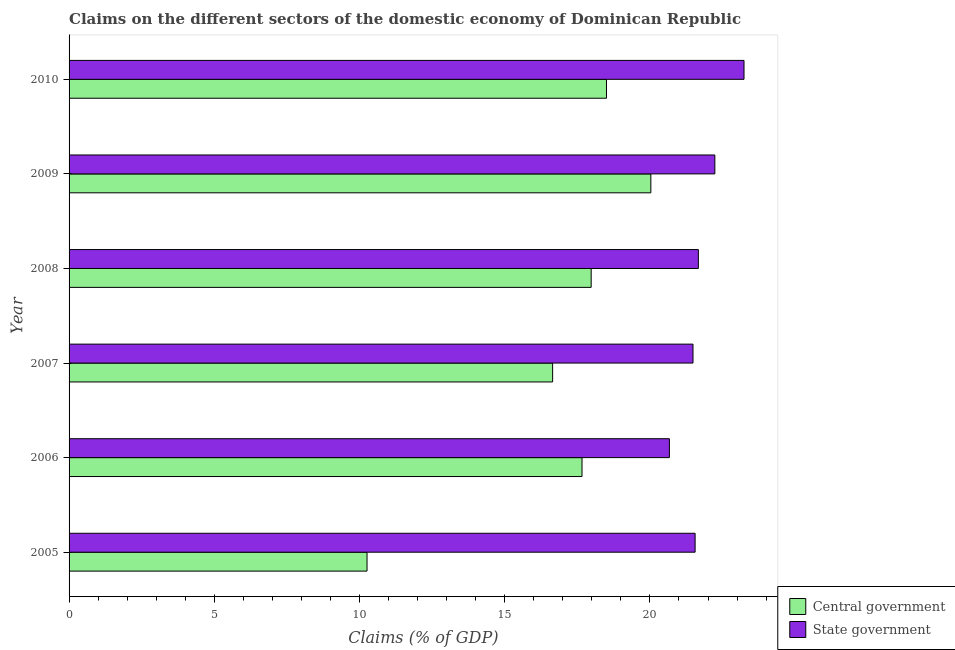How many different coloured bars are there?
Keep it short and to the point. 2. How many groups of bars are there?
Your response must be concise. 6. Are the number of bars per tick equal to the number of legend labels?
Keep it short and to the point. Yes. Are the number of bars on each tick of the Y-axis equal?
Provide a succinct answer. Yes. How many bars are there on the 6th tick from the top?
Your answer should be compact. 2. What is the label of the 2nd group of bars from the top?
Offer a very short reply. 2009. What is the claims on central government in 2008?
Provide a short and direct response. 17.98. Across all years, what is the maximum claims on state government?
Provide a succinct answer. 23.24. Across all years, what is the minimum claims on state government?
Give a very brief answer. 20.67. What is the total claims on central government in the graph?
Provide a short and direct response. 101.08. What is the difference between the claims on central government in 2006 and that in 2007?
Offer a very short reply. 1.01. What is the difference between the claims on state government in 2005 and the claims on central government in 2006?
Your answer should be compact. 3.89. What is the average claims on central government per year?
Your answer should be compact. 16.85. In the year 2009, what is the difference between the claims on central government and claims on state government?
Ensure brevity in your answer.  -2.2. Is the claims on state government in 2005 less than that in 2006?
Your response must be concise. No. Is the difference between the claims on state government in 2008 and 2009 greater than the difference between the claims on central government in 2008 and 2009?
Make the answer very short. Yes. What is the difference between the highest and the second highest claims on state government?
Give a very brief answer. 1. What is the difference between the highest and the lowest claims on central government?
Provide a succinct answer. 9.77. In how many years, is the claims on state government greater than the average claims on state government taken over all years?
Give a very brief answer. 2. Is the sum of the claims on central government in 2007 and 2010 greater than the maximum claims on state government across all years?
Give a very brief answer. Yes. What does the 2nd bar from the top in 2010 represents?
Keep it short and to the point. Central government. What does the 2nd bar from the bottom in 2005 represents?
Your answer should be very brief. State government. How many bars are there?
Keep it short and to the point. 12. Are all the bars in the graph horizontal?
Your response must be concise. Yes. How many years are there in the graph?
Give a very brief answer. 6. Does the graph contain grids?
Your answer should be very brief. No. How are the legend labels stacked?
Ensure brevity in your answer.  Vertical. What is the title of the graph?
Offer a terse response. Claims on the different sectors of the domestic economy of Dominican Republic. What is the label or title of the X-axis?
Offer a terse response. Claims (% of GDP). What is the label or title of the Y-axis?
Your answer should be very brief. Year. What is the Claims (% of GDP) in Central government in 2005?
Make the answer very short. 10.26. What is the Claims (% of GDP) in State government in 2005?
Your response must be concise. 21.56. What is the Claims (% of GDP) in Central government in 2006?
Ensure brevity in your answer.  17.66. What is the Claims (% of GDP) in State government in 2006?
Make the answer very short. 20.67. What is the Claims (% of GDP) of Central government in 2007?
Your response must be concise. 16.65. What is the Claims (% of GDP) in State government in 2007?
Offer a terse response. 21.48. What is the Claims (% of GDP) in Central government in 2008?
Your answer should be compact. 17.98. What is the Claims (% of GDP) of State government in 2008?
Your answer should be compact. 21.67. What is the Claims (% of GDP) of Central government in 2009?
Offer a terse response. 20.03. What is the Claims (% of GDP) of State government in 2009?
Provide a short and direct response. 22.24. What is the Claims (% of GDP) in Central government in 2010?
Provide a succinct answer. 18.5. What is the Claims (% of GDP) of State government in 2010?
Your answer should be compact. 23.24. Across all years, what is the maximum Claims (% of GDP) of Central government?
Offer a very short reply. 20.03. Across all years, what is the maximum Claims (% of GDP) of State government?
Provide a short and direct response. 23.24. Across all years, what is the minimum Claims (% of GDP) in Central government?
Offer a very short reply. 10.26. Across all years, what is the minimum Claims (% of GDP) of State government?
Provide a succinct answer. 20.67. What is the total Claims (% of GDP) of Central government in the graph?
Ensure brevity in your answer.  101.08. What is the total Claims (% of GDP) of State government in the graph?
Make the answer very short. 130.85. What is the difference between the Claims (% of GDP) of Central government in 2005 and that in 2006?
Your response must be concise. -7.4. What is the difference between the Claims (% of GDP) in State government in 2005 and that in 2006?
Give a very brief answer. 0.89. What is the difference between the Claims (% of GDP) of Central government in 2005 and that in 2007?
Offer a very short reply. -6.39. What is the difference between the Claims (% of GDP) in State government in 2005 and that in 2007?
Your response must be concise. 0.07. What is the difference between the Claims (% of GDP) of Central government in 2005 and that in 2008?
Provide a short and direct response. -7.72. What is the difference between the Claims (% of GDP) of State government in 2005 and that in 2008?
Your answer should be compact. -0.11. What is the difference between the Claims (% of GDP) of Central government in 2005 and that in 2009?
Ensure brevity in your answer.  -9.77. What is the difference between the Claims (% of GDP) in State government in 2005 and that in 2009?
Your answer should be very brief. -0.68. What is the difference between the Claims (% of GDP) in Central government in 2005 and that in 2010?
Give a very brief answer. -8.24. What is the difference between the Claims (% of GDP) in State government in 2005 and that in 2010?
Offer a terse response. -1.68. What is the difference between the Claims (% of GDP) of Central government in 2006 and that in 2007?
Provide a short and direct response. 1.01. What is the difference between the Claims (% of GDP) in State government in 2006 and that in 2007?
Give a very brief answer. -0.81. What is the difference between the Claims (% of GDP) in Central government in 2006 and that in 2008?
Give a very brief answer. -0.32. What is the difference between the Claims (% of GDP) of State government in 2006 and that in 2008?
Provide a succinct answer. -1. What is the difference between the Claims (% of GDP) in Central government in 2006 and that in 2009?
Your answer should be compact. -2.37. What is the difference between the Claims (% of GDP) in State government in 2006 and that in 2009?
Your answer should be very brief. -1.56. What is the difference between the Claims (% of GDP) in Central government in 2006 and that in 2010?
Provide a short and direct response. -0.84. What is the difference between the Claims (% of GDP) of State government in 2006 and that in 2010?
Provide a succinct answer. -2.57. What is the difference between the Claims (% of GDP) in Central government in 2007 and that in 2008?
Make the answer very short. -1.33. What is the difference between the Claims (% of GDP) of State government in 2007 and that in 2008?
Provide a short and direct response. -0.18. What is the difference between the Claims (% of GDP) in Central government in 2007 and that in 2009?
Your answer should be compact. -3.38. What is the difference between the Claims (% of GDP) in State government in 2007 and that in 2009?
Offer a very short reply. -0.75. What is the difference between the Claims (% of GDP) in Central government in 2007 and that in 2010?
Ensure brevity in your answer.  -1.85. What is the difference between the Claims (% of GDP) in State government in 2007 and that in 2010?
Ensure brevity in your answer.  -1.76. What is the difference between the Claims (% of GDP) of Central government in 2008 and that in 2009?
Keep it short and to the point. -2.05. What is the difference between the Claims (% of GDP) of State government in 2008 and that in 2009?
Keep it short and to the point. -0.57. What is the difference between the Claims (% of GDP) of Central government in 2008 and that in 2010?
Ensure brevity in your answer.  -0.53. What is the difference between the Claims (% of GDP) of State government in 2008 and that in 2010?
Ensure brevity in your answer.  -1.57. What is the difference between the Claims (% of GDP) in Central government in 2009 and that in 2010?
Ensure brevity in your answer.  1.53. What is the difference between the Claims (% of GDP) of State government in 2009 and that in 2010?
Keep it short and to the point. -1. What is the difference between the Claims (% of GDP) of Central government in 2005 and the Claims (% of GDP) of State government in 2006?
Your response must be concise. -10.41. What is the difference between the Claims (% of GDP) in Central government in 2005 and the Claims (% of GDP) in State government in 2007?
Your answer should be very brief. -11.22. What is the difference between the Claims (% of GDP) of Central government in 2005 and the Claims (% of GDP) of State government in 2008?
Your response must be concise. -11.41. What is the difference between the Claims (% of GDP) in Central government in 2005 and the Claims (% of GDP) in State government in 2009?
Offer a terse response. -11.98. What is the difference between the Claims (% of GDP) of Central government in 2005 and the Claims (% of GDP) of State government in 2010?
Offer a very short reply. -12.98. What is the difference between the Claims (% of GDP) of Central government in 2006 and the Claims (% of GDP) of State government in 2007?
Offer a terse response. -3.82. What is the difference between the Claims (% of GDP) in Central government in 2006 and the Claims (% of GDP) in State government in 2008?
Make the answer very short. -4.01. What is the difference between the Claims (% of GDP) in Central government in 2006 and the Claims (% of GDP) in State government in 2009?
Your answer should be compact. -4.57. What is the difference between the Claims (% of GDP) of Central government in 2006 and the Claims (% of GDP) of State government in 2010?
Make the answer very short. -5.58. What is the difference between the Claims (% of GDP) in Central government in 2007 and the Claims (% of GDP) in State government in 2008?
Keep it short and to the point. -5.02. What is the difference between the Claims (% of GDP) of Central government in 2007 and the Claims (% of GDP) of State government in 2009?
Your answer should be compact. -5.59. What is the difference between the Claims (% of GDP) of Central government in 2007 and the Claims (% of GDP) of State government in 2010?
Keep it short and to the point. -6.59. What is the difference between the Claims (% of GDP) in Central government in 2008 and the Claims (% of GDP) in State government in 2009?
Provide a succinct answer. -4.26. What is the difference between the Claims (% of GDP) of Central government in 2008 and the Claims (% of GDP) of State government in 2010?
Provide a succinct answer. -5.26. What is the difference between the Claims (% of GDP) in Central government in 2009 and the Claims (% of GDP) in State government in 2010?
Keep it short and to the point. -3.21. What is the average Claims (% of GDP) of Central government per year?
Keep it short and to the point. 16.85. What is the average Claims (% of GDP) of State government per year?
Ensure brevity in your answer.  21.81. In the year 2005, what is the difference between the Claims (% of GDP) of Central government and Claims (% of GDP) of State government?
Provide a short and direct response. -11.3. In the year 2006, what is the difference between the Claims (% of GDP) of Central government and Claims (% of GDP) of State government?
Make the answer very short. -3.01. In the year 2007, what is the difference between the Claims (% of GDP) of Central government and Claims (% of GDP) of State government?
Your response must be concise. -4.83. In the year 2008, what is the difference between the Claims (% of GDP) of Central government and Claims (% of GDP) of State government?
Make the answer very short. -3.69. In the year 2009, what is the difference between the Claims (% of GDP) of Central government and Claims (% of GDP) of State government?
Offer a terse response. -2.2. In the year 2010, what is the difference between the Claims (% of GDP) of Central government and Claims (% of GDP) of State government?
Provide a short and direct response. -4.74. What is the ratio of the Claims (% of GDP) of Central government in 2005 to that in 2006?
Ensure brevity in your answer.  0.58. What is the ratio of the Claims (% of GDP) of State government in 2005 to that in 2006?
Your answer should be compact. 1.04. What is the ratio of the Claims (% of GDP) of Central government in 2005 to that in 2007?
Provide a succinct answer. 0.62. What is the ratio of the Claims (% of GDP) in State government in 2005 to that in 2007?
Your answer should be compact. 1. What is the ratio of the Claims (% of GDP) of Central government in 2005 to that in 2008?
Your answer should be very brief. 0.57. What is the ratio of the Claims (% of GDP) in State government in 2005 to that in 2008?
Provide a succinct answer. 0.99. What is the ratio of the Claims (% of GDP) of Central government in 2005 to that in 2009?
Provide a succinct answer. 0.51. What is the ratio of the Claims (% of GDP) in State government in 2005 to that in 2009?
Your answer should be very brief. 0.97. What is the ratio of the Claims (% of GDP) in Central government in 2005 to that in 2010?
Make the answer very short. 0.55. What is the ratio of the Claims (% of GDP) of State government in 2005 to that in 2010?
Make the answer very short. 0.93. What is the ratio of the Claims (% of GDP) of Central government in 2006 to that in 2007?
Offer a terse response. 1.06. What is the ratio of the Claims (% of GDP) in State government in 2006 to that in 2007?
Your response must be concise. 0.96. What is the ratio of the Claims (% of GDP) of Central government in 2006 to that in 2008?
Make the answer very short. 0.98. What is the ratio of the Claims (% of GDP) in State government in 2006 to that in 2008?
Offer a very short reply. 0.95. What is the ratio of the Claims (% of GDP) of Central government in 2006 to that in 2009?
Make the answer very short. 0.88. What is the ratio of the Claims (% of GDP) of State government in 2006 to that in 2009?
Make the answer very short. 0.93. What is the ratio of the Claims (% of GDP) of Central government in 2006 to that in 2010?
Your response must be concise. 0.95. What is the ratio of the Claims (% of GDP) of State government in 2006 to that in 2010?
Offer a terse response. 0.89. What is the ratio of the Claims (% of GDP) of Central government in 2007 to that in 2008?
Provide a succinct answer. 0.93. What is the ratio of the Claims (% of GDP) of Central government in 2007 to that in 2009?
Your answer should be very brief. 0.83. What is the ratio of the Claims (% of GDP) of State government in 2007 to that in 2009?
Ensure brevity in your answer.  0.97. What is the ratio of the Claims (% of GDP) in Central government in 2007 to that in 2010?
Keep it short and to the point. 0.9. What is the ratio of the Claims (% of GDP) of State government in 2007 to that in 2010?
Your answer should be compact. 0.92. What is the ratio of the Claims (% of GDP) in Central government in 2008 to that in 2009?
Your answer should be compact. 0.9. What is the ratio of the Claims (% of GDP) in State government in 2008 to that in 2009?
Your answer should be very brief. 0.97. What is the ratio of the Claims (% of GDP) of Central government in 2008 to that in 2010?
Ensure brevity in your answer.  0.97. What is the ratio of the Claims (% of GDP) of State government in 2008 to that in 2010?
Provide a succinct answer. 0.93. What is the ratio of the Claims (% of GDP) of Central government in 2009 to that in 2010?
Your answer should be compact. 1.08. What is the ratio of the Claims (% of GDP) in State government in 2009 to that in 2010?
Provide a short and direct response. 0.96. What is the difference between the highest and the second highest Claims (% of GDP) in Central government?
Provide a short and direct response. 1.53. What is the difference between the highest and the lowest Claims (% of GDP) in Central government?
Offer a very short reply. 9.77. What is the difference between the highest and the lowest Claims (% of GDP) of State government?
Offer a terse response. 2.57. 